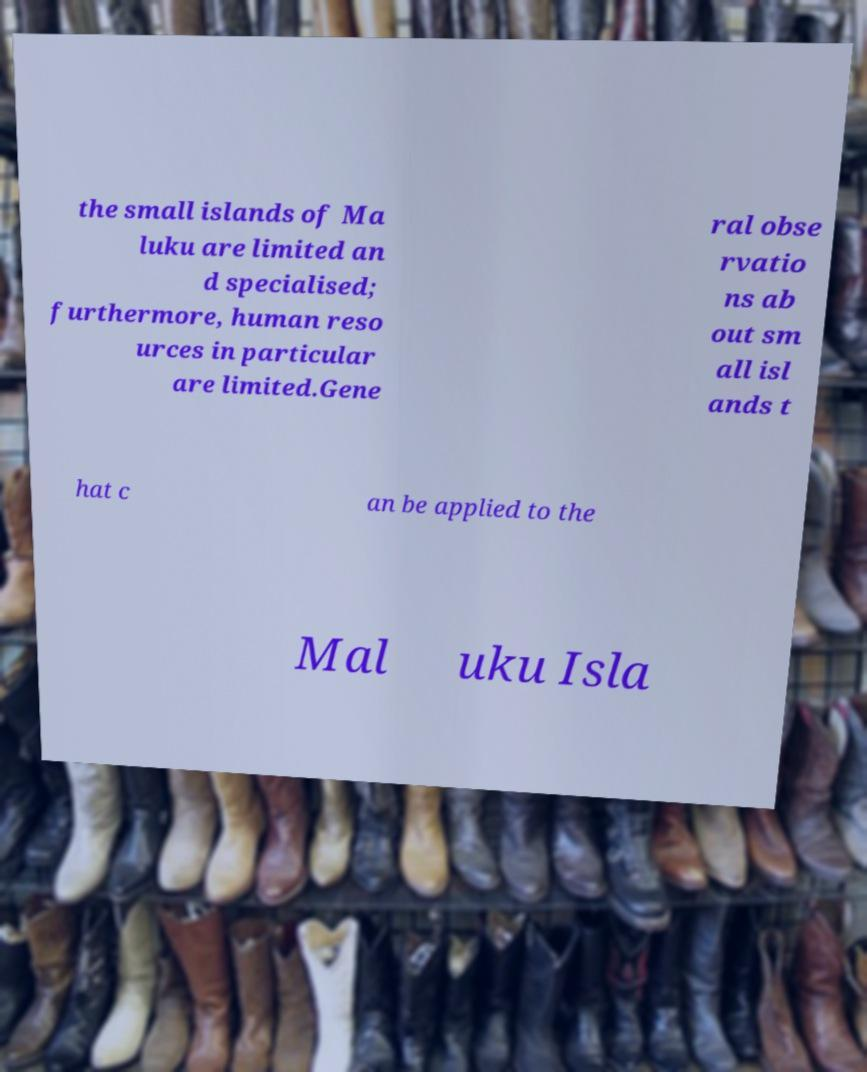Can you accurately transcribe the text from the provided image for me? the small islands of Ma luku are limited an d specialised; furthermore, human reso urces in particular are limited.Gene ral obse rvatio ns ab out sm all isl ands t hat c an be applied to the Mal uku Isla 